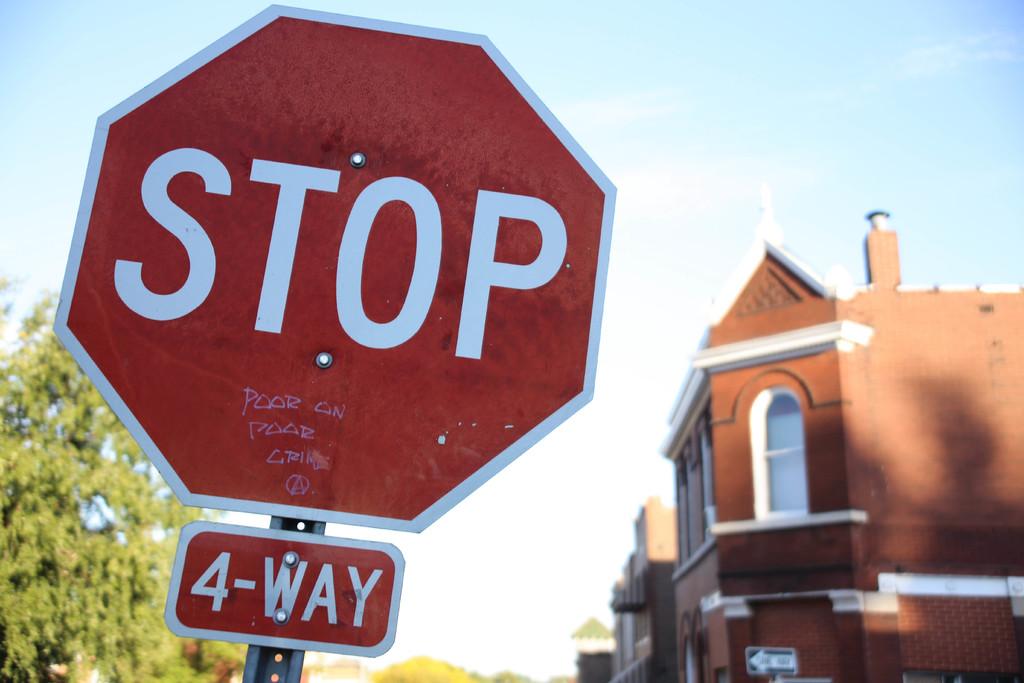What does this sign stand for?
Keep it short and to the point. Stop. What does the bottom sign say?
Offer a very short reply. 4-way. 